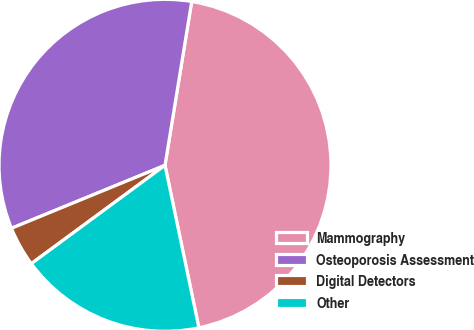Convert chart. <chart><loc_0><loc_0><loc_500><loc_500><pie_chart><fcel>Mammography<fcel>Osteoporosis Assessment<fcel>Digital Detectors<fcel>Other<nl><fcel>44.16%<fcel>33.77%<fcel>3.9%<fcel>18.18%<nl></chart> 